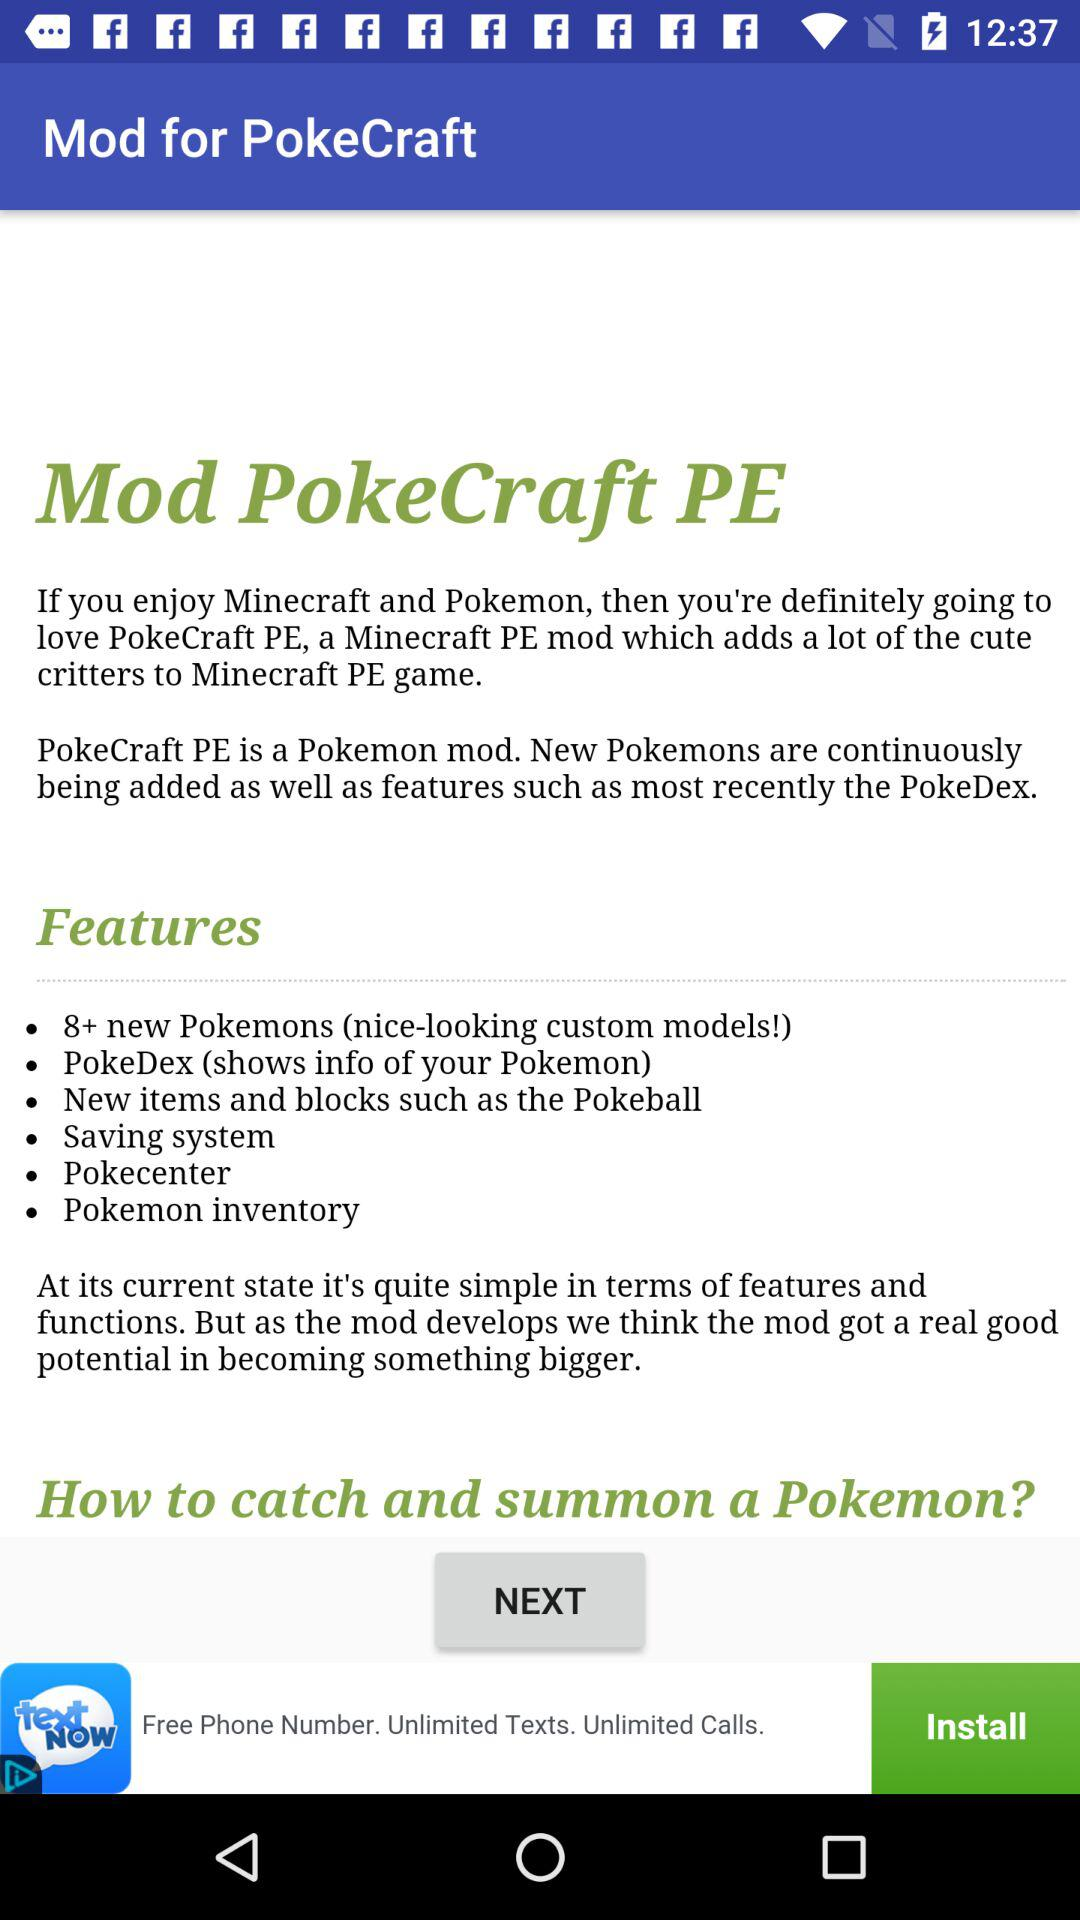What is the full form of Mod Poke Craft PE?
When the provided information is insufficient, respond with <no answer>. <no answer> 